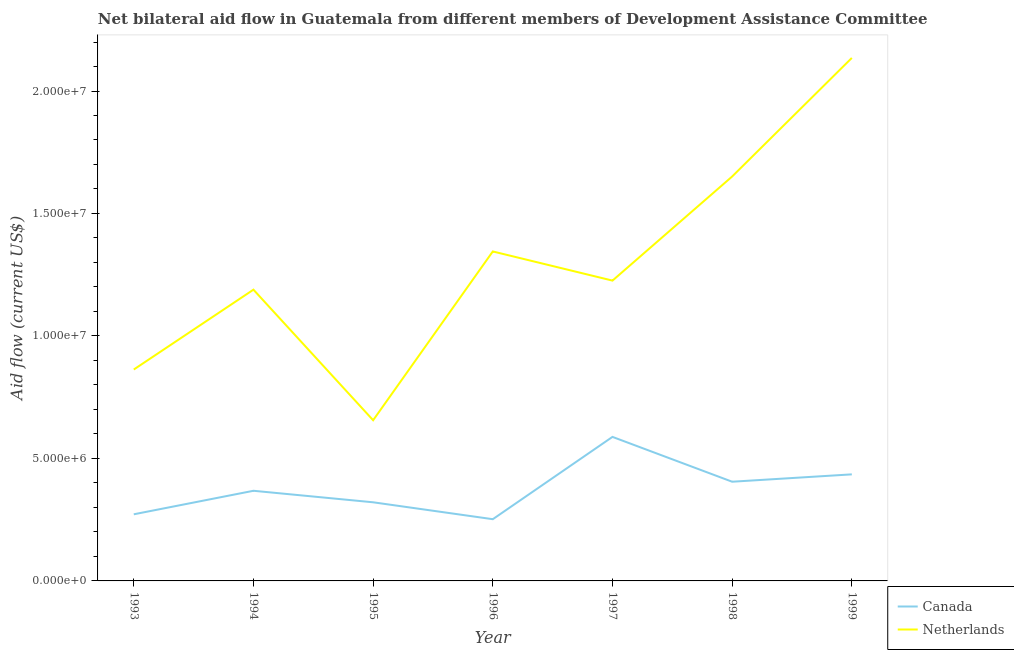Does the line corresponding to amount of aid given by canada intersect with the line corresponding to amount of aid given by netherlands?
Give a very brief answer. No. Is the number of lines equal to the number of legend labels?
Give a very brief answer. Yes. What is the amount of aid given by canada in 1995?
Keep it short and to the point. 3.21e+06. Across all years, what is the maximum amount of aid given by netherlands?
Give a very brief answer. 2.14e+07. Across all years, what is the minimum amount of aid given by netherlands?
Keep it short and to the point. 6.56e+06. In which year was the amount of aid given by netherlands maximum?
Provide a succinct answer. 1999. In which year was the amount of aid given by canada minimum?
Give a very brief answer. 1996. What is the total amount of aid given by canada in the graph?
Keep it short and to the point. 2.64e+07. What is the difference between the amount of aid given by canada in 1994 and that in 1997?
Offer a very short reply. -2.20e+06. What is the difference between the amount of aid given by canada in 1996 and the amount of aid given by netherlands in 1995?
Keep it short and to the point. -4.04e+06. What is the average amount of aid given by canada per year?
Offer a very short reply. 3.77e+06. In the year 1998, what is the difference between the amount of aid given by canada and amount of aid given by netherlands?
Offer a terse response. -1.25e+07. What is the ratio of the amount of aid given by canada in 1997 to that in 1998?
Provide a short and direct response. 1.45. Is the amount of aid given by canada in 1994 less than that in 1996?
Make the answer very short. No. What is the difference between the highest and the second highest amount of aid given by netherlands?
Keep it short and to the point. 4.84e+06. What is the difference between the highest and the lowest amount of aid given by canada?
Your response must be concise. 3.36e+06. In how many years, is the amount of aid given by netherlands greater than the average amount of aid given by netherlands taken over all years?
Provide a short and direct response. 3. Does the amount of aid given by netherlands monotonically increase over the years?
Offer a very short reply. No. Is the amount of aid given by canada strictly greater than the amount of aid given by netherlands over the years?
Your answer should be compact. No. Is the amount of aid given by netherlands strictly less than the amount of aid given by canada over the years?
Give a very brief answer. No. What is the difference between two consecutive major ticks on the Y-axis?
Ensure brevity in your answer.  5.00e+06. Does the graph contain grids?
Give a very brief answer. No. How many legend labels are there?
Ensure brevity in your answer.  2. What is the title of the graph?
Provide a succinct answer. Net bilateral aid flow in Guatemala from different members of Development Assistance Committee. Does "Food" appear as one of the legend labels in the graph?
Your response must be concise. No. What is the Aid flow (current US$) of Canada in 1993?
Offer a very short reply. 2.72e+06. What is the Aid flow (current US$) in Netherlands in 1993?
Give a very brief answer. 8.63e+06. What is the Aid flow (current US$) in Canada in 1994?
Provide a short and direct response. 3.68e+06. What is the Aid flow (current US$) in Netherlands in 1994?
Provide a succinct answer. 1.19e+07. What is the Aid flow (current US$) in Canada in 1995?
Provide a succinct answer. 3.21e+06. What is the Aid flow (current US$) of Netherlands in 1995?
Ensure brevity in your answer.  6.56e+06. What is the Aid flow (current US$) in Canada in 1996?
Your response must be concise. 2.52e+06. What is the Aid flow (current US$) of Netherlands in 1996?
Provide a succinct answer. 1.34e+07. What is the Aid flow (current US$) in Canada in 1997?
Your response must be concise. 5.88e+06. What is the Aid flow (current US$) of Netherlands in 1997?
Keep it short and to the point. 1.23e+07. What is the Aid flow (current US$) in Canada in 1998?
Your answer should be very brief. 4.05e+06. What is the Aid flow (current US$) in Netherlands in 1998?
Provide a short and direct response. 1.65e+07. What is the Aid flow (current US$) of Canada in 1999?
Provide a succinct answer. 4.35e+06. What is the Aid flow (current US$) of Netherlands in 1999?
Offer a very short reply. 2.14e+07. Across all years, what is the maximum Aid flow (current US$) in Canada?
Make the answer very short. 5.88e+06. Across all years, what is the maximum Aid flow (current US$) of Netherlands?
Your answer should be compact. 2.14e+07. Across all years, what is the minimum Aid flow (current US$) of Canada?
Offer a terse response. 2.52e+06. Across all years, what is the minimum Aid flow (current US$) in Netherlands?
Offer a terse response. 6.56e+06. What is the total Aid flow (current US$) of Canada in the graph?
Your response must be concise. 2.64e+07. What is the total Aid flow (current US$) of Netherlands in the graph?
Your answer should be compact. 9.06e+07. What is the difference between the Aid flow (current US$) in Canada in 1993 and that in 1994?
Make the answer very short. -9.60e+05. What is the difference between the Aid flow (current US$) of Netherlands in 1993 and that in 1994?
Your answer should be compact. -3.26e+06. What is the difference between the Aid flow (current US$) in Canada in 1993 and that in 1995?
Provide a succinct answer. -4.90e+05. What is the difference between the Aid flow (current US$) in Netherlands in 1993 and that in 1995?
Offer a very short reply. 2.07e+06. What is the difference between the Aid flow (current US$) in Netherlands in 1993 and that in 1996?
Your response must be concise. -4.82e+06. What is the difference between the Aid flow (current US$) of Canada in 1993 and that in 1997?
Provide a short and direct response. -3.16e+06. What is the difference between the Aid flow (current US$) in Netherlands in 1993 and that in 1997?
Your response must be concise. -3.63e+06. What is the difference between the Aid flow (current US$) of Canada in 1993 and that in 1998?
Provide a short and direct response. -1.33e+06. What is the difference between the Aid flow (current US$) of Netherlands in 1993 and that in 1998?
Your answer should be compact. -7.88e+06. What is the difference between the Aid flow (current US$) in Canada in 1993 and that in 1999?
Your answer should be very brief. -1.63e+06. What is the difference between the Aid flow (current US$) in Netherlands in 1993 and that in 1999?
Make the answer very short. -1.27e+07. What is the difference between the Aid flow (current US$) of Netherlands in 1994 and that in 1995?
Provide a succinct answer. 5.33e+06. What is the difference between the Aid flow (current US$) in Canada in 1994 and that in 1996?
Your response must be concise. 1.16e+06. What is the difference between the Aid flow (current US$) in Netherlands in 1994 and that in 1996?
Your response must be concise. -1.56e+06. What is the difference between the Aid flow (current US$) in Canada in 1994 and that in 1997?
Give a very brief answer. -2.20e+06. What is the difference between the Aid flow (current US$) of Netherlands in 1994 and that in 1997?
Ensure brevity in your answer.  -3.70e+05. What is the difference between the Aid flow (current US$) of Canada in 1994 and that in 1998?
Ensure brevity in your answer.  -3.70e+05. What is the difference between the Aid flow (current US$) in Netherlands in 1994 and that in 1998?
Offer a terse response. -4.62e+06. What is the difference between the Aid flow (current US$) of Canada in 1994 and that in 1999?
Ensure brevity in your answer.  -6.70e+05. What is the difference between the Aid flow (current US$) in Netherlands in 1994 and that in 1999?
Your response must be concise. -9.46e+06. What is the difference between the Aid flow (current US$) in Canada in 1995 and that in 1996?
Provide a succinct answer. 6.90e+05. What is the difference between the Aid flow (current US$) of Netherlands in 1995 and that in 1996?
Ensure brevity in your answer.  -6.89e+06. What is the difference between the Aid flow (current US$) of Canada in 1995 and that in 1997?
Offer a terse response. -2.67e+06. What is the difference between the Aid flow (current US$) of Netherlands in 1995 and that in 1997?
Provide a succinct answer. -5.70e+06. What is the difference between the Aid flow (current US$) in Canada in 1995 and that in 1998?
Offer a terse response. -8.40e+05. What is the difference between the Aid flow (current US$) in Netherlands in 1995 and that in 1998?
Your answer should be compact. -9.95e+06. What is the difference between the Aid flow (current US$) in Canada in 1995 and that in 1999?
Your answer should be very brief. -1.14e+06. What is the difference between the Aid flow (current US$) of Netherlands in 1995 and that in 1999?
Provide a short and direct response. -1.48e+07. What is the difference between the Aid flow (current US$) of Canada in 1996 and that in 1997?
Provide a succinct answer. -3.36e+06. What is the difference between the Aid flow (current US$) of Netherlands in 1996 and that in 1997?
Your answer should be compact. 1.19e+06. What is the difference between the Aid flow (current US$) in Canada in 1996 and that in 1998?
Offer a very short reply. -1.53e+06. What is the difference between the Aid flow (current US$) in Netherlands in 1996 and that in 1998?
Your answer should be compact. -3.06e+06. What is the difference between the Aid flow (current US$) in Canada in 1996 and that in 1999?
Make the answer very short. -1.83e+06. What is the difference between the Aid flow (current US$) of Netherlands in 1996 and that in 1999?
Provide a succinct answer. -7.90e+06. What is the difference between the Aid flow (current US$) in Canada in 1997 and that in 1998?
Provide a short and direct response. 1.83e+06. What is the difference between the Aid flow (current US$) of Netherlands in 1997 and that in 1998?
Provide a short and direct response. -4.25e+06. What is the difference between the Aid flow (current US$) of Canada in 1997 and that in 1999?
Keep it short and to the point. 1.53e+06. What is the difference between the Aid flow (current US$) in Netherlands in 1997 and that in 1999?
Ensure brevity in your answer.  -9.09e+06. What is the difference between the Aid flow (current US$) in Canada in 1998 and that in 1999?
Your answer should be compact. -3.00e+05. What is the difference between the Aid flow (current US$) in Netherlands in 1998 and that in 1999?
Give a very brief answer. -4.84e+06. What is the difference between the Aid flow (current US$) in Canada in 1993 and the Aid flow (current US$) in Netherlands in 1994?
Offer a very short reply. -9.17e+06. What is the difference between the Aid flow (current US$) in Canada in 1993 and the Aid flow (current US$) in Netherlands in 1995?
Your answer should be compact. -3.84e+06. What is the difference between the Aid flow (current US$) of Canada in 1993 and the Aid flow (current US$) of Netherlands in 1996?
Offer a very short reply. -1.07e+07. What is the difference between the Aid flow (current US$) in Canada in 1993 and the Aid flow (current US$) in Netherlands in 1997?
Offer a terse response. -9.54e+06. What is the difference between the Aid flow (current US$) in Canada in 1993 and the Aid flow (current US$) in Netherlands in 1998?
Offer a very short reply. -1.38e+07. What is the difference between the Aid flow (current US$) of Canada in 1993 and the Aid flow (current US$) of Netherlands in 1999?
Provide a short and direct response. -1.86e+07. What is the difference between the Aid flow (current US$) of Canada in 1994 and the Aid flow (current US$) of Netherlands in 1995?
Make the answer very short. -2.88e+06. What is the difference between the Aid flow (current US$) in Canada in 1994 and the Aid flow (current US$) in Netherlands in 1996?
Your answer should be very brief. -9.77e+06. What is the difference between the Aid flow (current US$) in Canada in 1994 and the Aid flow (current US$) in Netherlands in 1997?
Your answer should be very brief. -8.58e+06. What is the difference between the Aid flow (current US$) of Canada in 1994 and the Aid flow (current US$) of Netherlands in 1998?
Your answer should be compact. -1.28e+07. What is the difference between the Aid flow (current US$) in Canada in 1994 and the Aid flow (current US$) in Netherlands in 1999?
Your answer should be compact. -1.77e+07. What is the difference between the Aid flow (current US$) in Canada in 1995 and the Aid flow (current US$) in Netherlands in 1996?
Your answer should be very brief. -1.02e+07. What is the difference between the Aid flow (current US$) of Canada in 1995 and the Aid flow (current US$) of Netherlands in 1997?
Give a very brief answer. -9.05e+06. What is the difference between the Aid flow (current US$) in Canada in 1995 and the Aid flow (current US$) in Netherlands in 1998?
Your response must be concise. -1.33e+07. What is the difference between the Aid flow (current US$) of Canada in 1995 and the Aid flow (current US$) of Netherlands in 1999?
Keep it short and to the point. -1.81e+07. What is the difference between the Aid flow (current US$) in Canada in 1996 and the Aid flow (current US$) in Netherlands in 1997?
Make the answer very short. -9.74e+06. What is the difference between the Aid flow (current US$) in Canada in 1996 and the Aid flow (current US$) in Netherlands in 1998?
Keep it short and to the point. -1.40e+07. What is the difference between the Aid flow (current US$) in Canada in 1996 and the Aid flow (current US$) in Netherlands in 1999?
Ensure brevity in your answer.  -1.88e+07. What is the difference between the Aid flow (current US$) of Canada in 1997 and the Aid flow (current US$) of Netherlands in 1998?
Provide a short and direct response. -1.06e+07. What is the difference between the Aid flow (current US$) of Canada in 1997 and the Aid flow (current US$) of Netherlands in 1999?
Offer a very short reply. -1.55e+07. What is the difference between the Aid flow (current US$) of Canada in 1998 and the Aid flow (current US$) of Netherlands in 1999?
Provide a succinct answer. -1.73e+07. What is the average Aid flow (current US$) in Canada per year?
Ensure brevity in your answer.  3.77e+06. What is the average Aid flow (current US$) of Netherlands per year?
Give a very brief answer. 1.30e+07. In the year 1993, what is the difference between the Aid flow (current US$) in Canada and Aid flow (current US$) in Netherlands?
Offer a terse response. -5.91e+06. In the year 1994, what is the difference between the Aid flow (current US$) in Canada and Aid flow (current US$) in Netherlands?
Provide a succinct answer. -8.21e+06. In the year 1995, what is the difference between the Aid flow (current US$) in Canada and Aid flow (current US$) in Netherlands?
Keep it short and to the point. -3.35e+06. In the year 1996, what is the difference between the Aid flow (current US$) in Canada and Aid flow (current US$) in Netherlands?
Provide a short and direct response. -1.09e+07. In the year 1997, what is the difference between the Aid flow (current US$) of Canada and Aid flow (current US$) of Netherlands?
Offer a very short reply. -6.38e+06. In the year 1998, what is the difference between the Aid flow (current US$) in Canada and Aid flow (current US$) in Netherlands?
Your response must be concise. -1.25e+07. In the year 1999, what is the difference between the Aid flow (current US$) in Canada and Aid flow (current US$) in Netherlands?
Make the answer very short. -1.70e+07. What is the ratio of the Aid flow (current US$) of Canada in 1993 to that in 1994?
Your answer should be compact. 0.74. What is the ratio of the Aid flow (current US$) of Netherlands in 1993 to that in 1994?
Make the answer very short. 0.73. What is the ratio of the Aid flow (current US$) of Canada in 1993 to that in 1995?
Keep it short and to the point. 0.85. What is the ratio of the Aid flow (current US$) of Netherlands in 1993 to that in 1995?
Offer a terse response. 1.32. What is the ratio of the Aid flow (current US$) in Canada in 1993 to that in 1996?
Offer a terse response. 1.08. What is the ratio of the Aid flow (current US$) in Netherlands in 1993 to that in 1996?
Your answer should be compact. 0.64. What is the ratio of the Aid flow (current US$) of Canada in 1993 to that in 1997?
Ensure brevity in your answer.  0.46. What is the ratio of the Aid flow (current US$) in Netherlands in 1993 to that in 1997?
Keep it short and to the point. 0.7. What is the ratio of the Aid flow (current US$) of Canada in 1993 to that in 1998?
Keep it short and to the point. 0.67. What is the ratio of the Aid flow (current US$) in Netherlands in 1993 to that in 1998?
Offer a terse response. 0.52. What is the ratio of the Aid flow (current US$) of Canada in 1993 to that in 1999?
Offer a very short reply. 0.63. What is the ratio of the Aid flow (current US$) in Netherlands in 1993 to that in 1999?
Make the answer very short. 0.4. What is the ratio of the Aid flow (current US$) of Canada in 1994 to that in 1995?
Make the answer very short. 1.15. What is the ratio of the Aid flow (current US$) of Netherlands in 1994 to that in 1995?
Your response must be concise. 1.81. What is the ratio of the Aid flow (current US$) in Canada in 1994 to that in 1996?
Your response must be concise. 1.46. What is the ratio of the Aid flow (current US$) in Netherlands in 1994 to that in 1996?
Give a very brief answer. 0.88. What is the ratio of the Aid flow (current US$) of Canada in 1994 to that in 1997?
Provide a short and direct response. 0.63. What is the ratio of the Aid flow (current US$) in Netherlands in 1994 to that in 1997?
Keep it short and to the point. 0.97. What is the ratio of the Aid flow (current US$) in Canada in 1994 to that in 1998?
Make the answer very short. 0.91. What is the ratio of the Aid flow (current US$) of Netherlands in 1994 to that in 1998?
Your answer should be very brief. 0.72. What is the ratio of the Aid flow (current US$) of Canada in 1994 to that in 1999?
Ensure brevity in your answer.  0.85. What is the ratio of the Aid flow (current US$) in Netherlands in 1994 to that in 1999?
Your answer should be very brief. 0.56. What is the ratio of the Aid flow (current US$) of Canada in 1995 to that in 1996?
Provide a short and direct response. 1.27. What is the ratio of the Aid flow (current US$) in Netherlands in 1995 to that in 1996?
Provide a succinct answer. 0.49. What is the ratio of the Aid flow (current US$) in Canada in 1995 to that in 1997?
Give a very brief answer. 0.55. What is the ratio of the Aid flow (current US$) of Netherlands in 1995 to that in 1997?
Keep it short and to the point. 0.54. What is the ratio of the Aid flow (current US$) in Canada in 1995 to that in 1998?
Your answer should be very brief. 0.79. What is the ratio of the Aid flow (current US$) of Netherlands in 1995 to that in 1998?
Make the answer very short. 0.4. What is the ratio of the Aid flow (current US$) in Canada in 1995 to that in 1999?
Your answer should be compact. 0.74. What is the ratio of the Aid flow (current US$) of Netherlands in 1995 to that in 1999?
Provide a succinct answer. 0.31. What is the ratio of the Aid flow (current US$) in Canada in 1996 to that in 1997?
Provide a succinct answer. 0.43. What is the ratio of the Aid flow (current US$) in Netherlands in 1996 to that in 1997?
Your answer should be very brief. 1.1. What is the ratio of the Aid flow (current US$) in Canada in 1996 to that in 1998?
Provide a short and direct response. 0.62. What is the ratio of the Aid flow (current US$) of Netherlands in 1996 to that in 1998?
Give a very brief answer. 0.81. What is the ratio of the Aid flow (current US$) of Canada in 1996 to that in 1999?
Your answer should be compact. 0.58. What is the ratio of the Aid flow (current US$) of Netherlands in 1996 to that in 1999?
Your answer should be very brief. 0.63. What is the ratio of the Aid flow (current US$) in Canada in 1997 to that in 1998?
Offer a very short reply. 1.45. What is the ratio of the Aid flow (current US$) of Netherlands in 1997 to that in 1998?
Make the answer very short. 0.74. What is the ratio of the Aid flow (current US$) of Canada in 1997 to that in 1999?
Ensure brevity in your answer.  1.35. What is the ratio of the Aid flow (current US$) of Netherlands in 1997 to that in 1999?
Ensure brevity in your answer.  0.57. What is the ratio of the Aid flow (current US$) in Canada in 1998 to that in 1999?
Provide a succinct answer. 0.93. What is the ratio of the Aid flow (current US$) in Netherlands in 1998 to that in 1999?
Your answer should be very brief. 0.77. What is the difference between the highest and the second highest Aid flow (current US$) in Canada?
Ensure brevity in your answer.  1.53e+06. What is the difference between the highest and the second highest Aid flow (current US$) in Netherlands?
Your answer should be very brief. 4.84e+06. What is the difference between the highest and the lowest Aid flow (current US$) of Canada?
Your answer should be compact. 3.36e+06. What is the difference between the highest and the lowest Aid flow (current US$) in Netherlands?
Offer a terse response. 1.48e+07. 